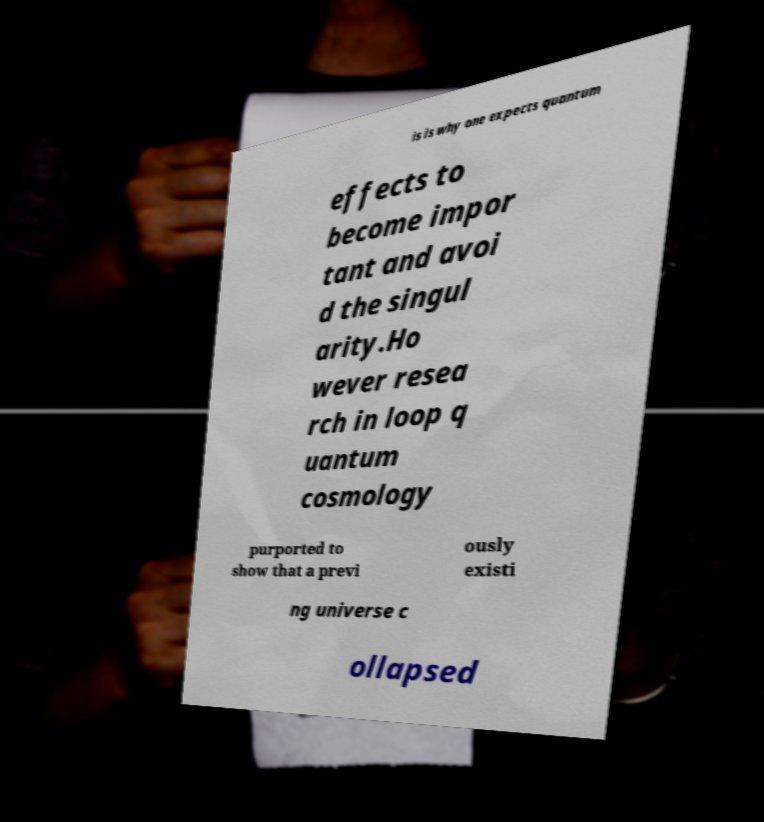Could you assist in decoding the text presented in this image and type it out clearly? is is why one expects quantum effects to become impor tant and avoi d the singul arity.Ho wever resea rch in loop q uantum cosmology purported to show that a previ ously existi ng universe c ollapsed 